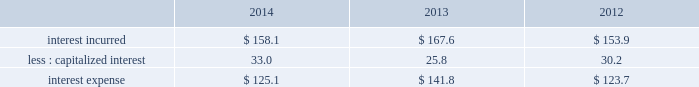Interest expense .
2014 vs .
2013 interest incurred decreased $ 9.5 .
The decrease was primarily due to a lower average interest rate on the debt portfolio which reduced interest by $ 13 , partially offset by a higher average debt balance which increased interest by $ 6 .
The change in capitalized interest was driven by a higher carrying value in construction in progress .
2013 vs .
2012 interest incurred increased $ 13.7 .
The increase was driven primarily by a higher average debt balance for $ 41 , partially offset by a lower average interest rate on the debt portfolio of $ 24 .
The change in capitalized interest was driven by a decrease in project spending and a lower average interest rate .
Effective tax rate the effective tax rate equals the income tax provision divided by income from continuing operations before taxes .
Refer to note 22 , income taxes , to the consolidated financial statements for details on factors affecting the effective tax rate .
2014 vs .
2013 on a gaap basis , the effective tax rate was 27.0% ( 27.0 % ) and 22.8% ( 22.8 % ) in 2014 and 2013 , respectively .
The effective tax rate was higher in the current year primarily due to the goodwill impairment charge of $ 305.2 , which was not deductible for tax purposes , and the chilean tax reform enacted in september 2014 which increased income tax expense by $ 20.6 .
These impacts were partially offset by an income tax benefit of $ 51.6 associated with losses from transactions and a tax election in a non-u.s .
Subsidiary .
The prior year rate included income tax benefits of $ 73.7 related to the business restructuring and cost reduction plans and $ 3.7 for the advisory costs .
Refer to note 4 , business restructuring and cost reduction actions ; note 9 , goodwill ; note 22 , income taxes ; and note 23 , supplemental information , to the consolidated financial statements for details on these transactions .
On a non-gaap basis , the effective tax rate was 24.0% ( 24.0 % ) and 24.2% ( 24.2 % ) in 2014 and 2013 , respectively .
2013 vs .
2012 on a gaap basis , the effective tax rate was 22.8% ( 22.8 % ) and 21.9% ( 21.9 % ) in 2013 and 2012 , respectively .
The effective rate in 2013 includes income tax benefits of $ 73.7 related to the business restructuring and cost reduction plans and $ 3.7 for the advisory costs .
The effective rate in 2012 includes income tax benefits of $ 105.0 related to the business restructuring and cost reduction plans , $ 58.3 related to the second quarter spanish tax ruling , and $ 3.7 related to the customer bankruptcy charge , offset by income tax expense of $ 43.8 related to the first quarter spanish tax settlement and $ 31.3 related to the gain on the previously held equity interest in da nanomaterials .
Refer to note 4 , business restructuring and cost reduction actions ; note 5 , business combinations ; note 22 , income taxes ; and note 23 , supplemental information , to the consolidated financial statements for details on these transactions .
On a non-gaap basis , the effective tax rate was 24.2% ( 24.2 % ) in both 2013 and 2012 .
Discontinued operations during the second quarter of 2012 , the board of directors authorized the sale of our homecare business , which had previously been reported as part of the merchant gases operating segment .
In 2012 , we sold the majority of our homecare business to the linde group for sale proceeds of 20ac590 million ( $ 777 ) and recognized a gain of $ 207.4 ( $ 150.3 after-tax , or $ .70 per share ) .
In addition , an impairment charge of $ 33.5 ( $ 29.5 after-tax , or $ .14 per share ) was recorded to write down the remaining business , which was primarily in the united kingdom and ireland , to its estimated net realizable value .
In 2013 , we recorded an additional charge of $ 18.7 ( $ 13.6 after-tax , or $ .06 per share ) to update our estimate of the net realizable value .
In 2014 , a gain of $ 3.9 was recognized for the sale of the remaining homecare business and settlement of contingencies on the sale to the linde group .
Refer to note 3 , discontinued operations , to the consolidated financial statements for additional details on this business. .
Considering the years 2012-2013 and the gaap basis , what was the percentual increase in the effective tax rate? 
Rationale: it is the variation between each year's effective tax rate .
Computations: (22.8 - 21.9)
Answer: 0.9. 